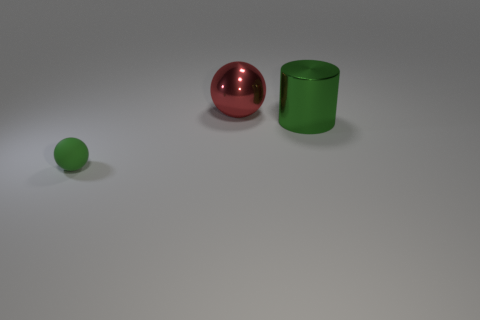Are there any other things that have the same material as the tiny sphere?
Your answer should be compact. No. There is a big thing that is made of the same material as the cylinder; what color is it?
Your response must be concise. Red. Is there any other thing that has the same size as the green matte ball?
Keep it short and to the point. No. Is the color of the object to the right of the shiny ball the same as the thing that is in front of the large green cylinder?
Your answer should be compact. Yes. Are there more large red things behind the cylinder than tiny green rubber spheres on the right side of the large red thing?
Offer a terse response. Yes. What is the color of the matte thing that is the same shape as the big red metallic thing?
Ensure brevity in your answer.  Green. Is there any other thing that has the same shape as the big green thing?
Your answer should be compact. No. There is a tiny thing; is it the same shape as the metallic thing that is to the left of the big cylinder?
Your answer should be compact. Yes. How many other objects are there of the same material as the red thing?
Provide a short and direct response. 1. Does the small matte ball have the same color as the big sphere left of the green cylinder?
Provide a succinct answer. No. 